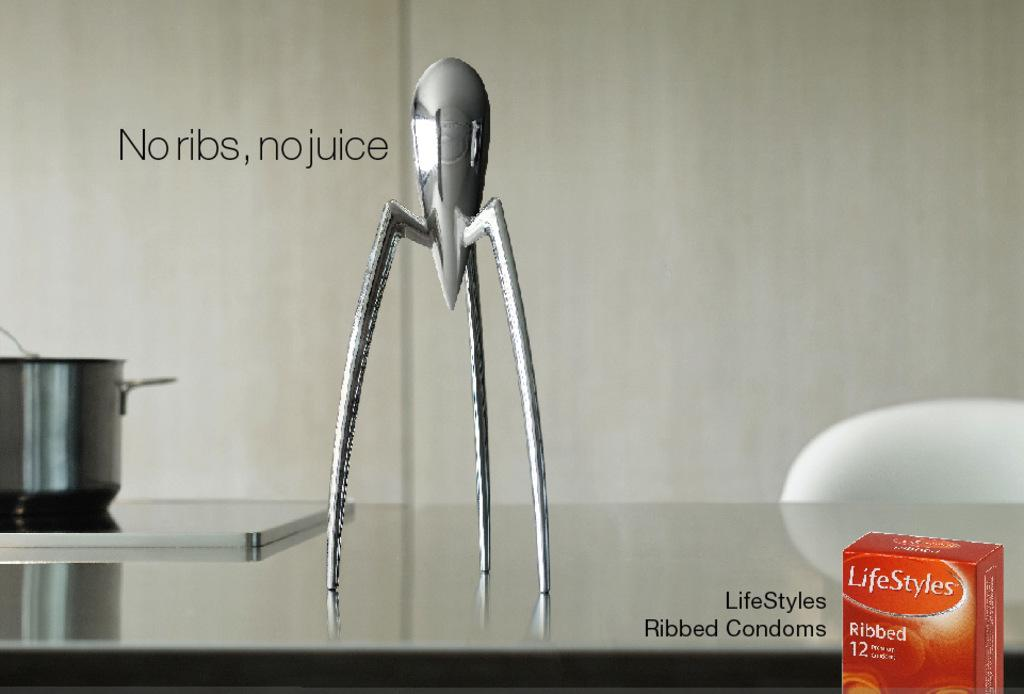What is the main subject in the image? There is a sculpture in the image. What other objects can be seen in the image? There is a bowl, a tray, and a red color box visible in the image. What is written or visible on the table? Text is visible on a table. What type of furniture is in front of the table? There is a chair in front of the table. What is the color of the background in the image? The background of the image is white. What type of drink is being served in the image? There is no drink present in the image. What type of grain is visible in the image? There is no grain visible in the image. 